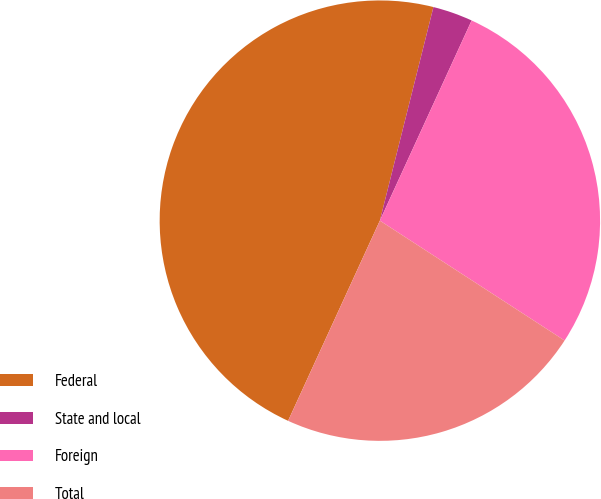<chart> <loc_0><loc_0><loc_500><loc_500><pie_chart><fcel>Federal<fcel>State and local<fcel>Foreign<fcel>Total<nl><fcel>47.07%<fcel>2.93%<fcel>27.32%<fcel>22.68%<nl></chart> 